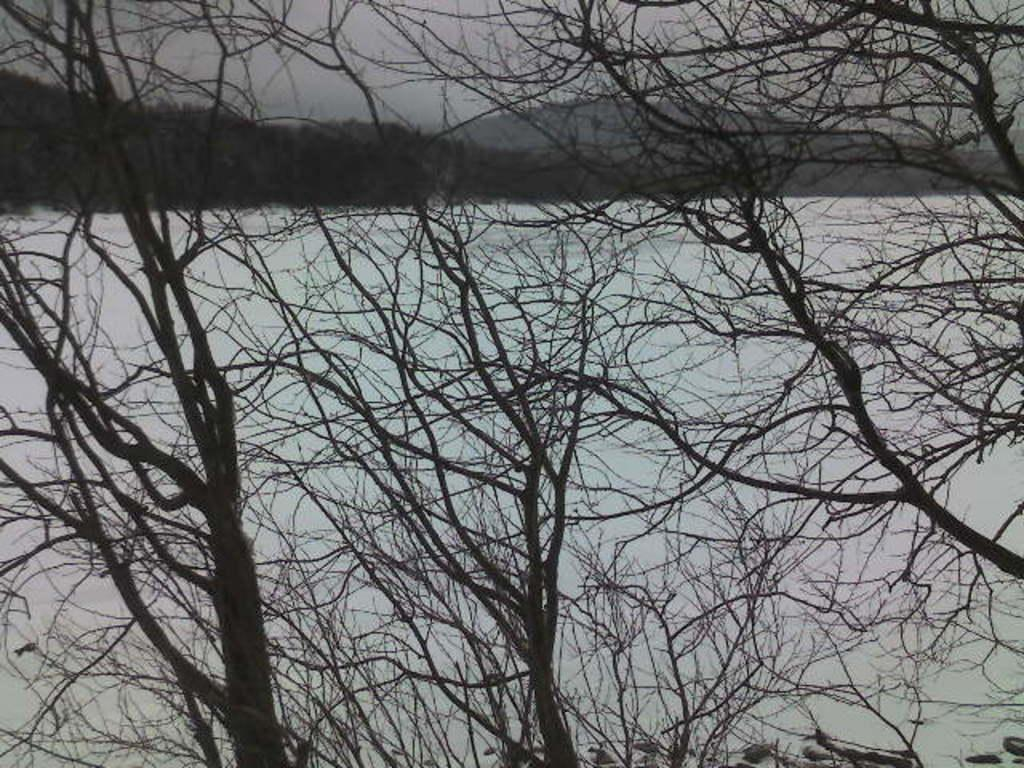What type of vegetation can be seen in the image? There are trees in the image. What is covering the ground in the image? There is snow at the bottom of the image. What part of the natural environment is visible in the image? The sky is visible at the top of the image. What type of request can be seen being made in the image? There is no request present in the image; it features trees, snow, and the sky. What finger is pointing at the trees in the image? There are no fingers or people present in the image to point at the trees. 